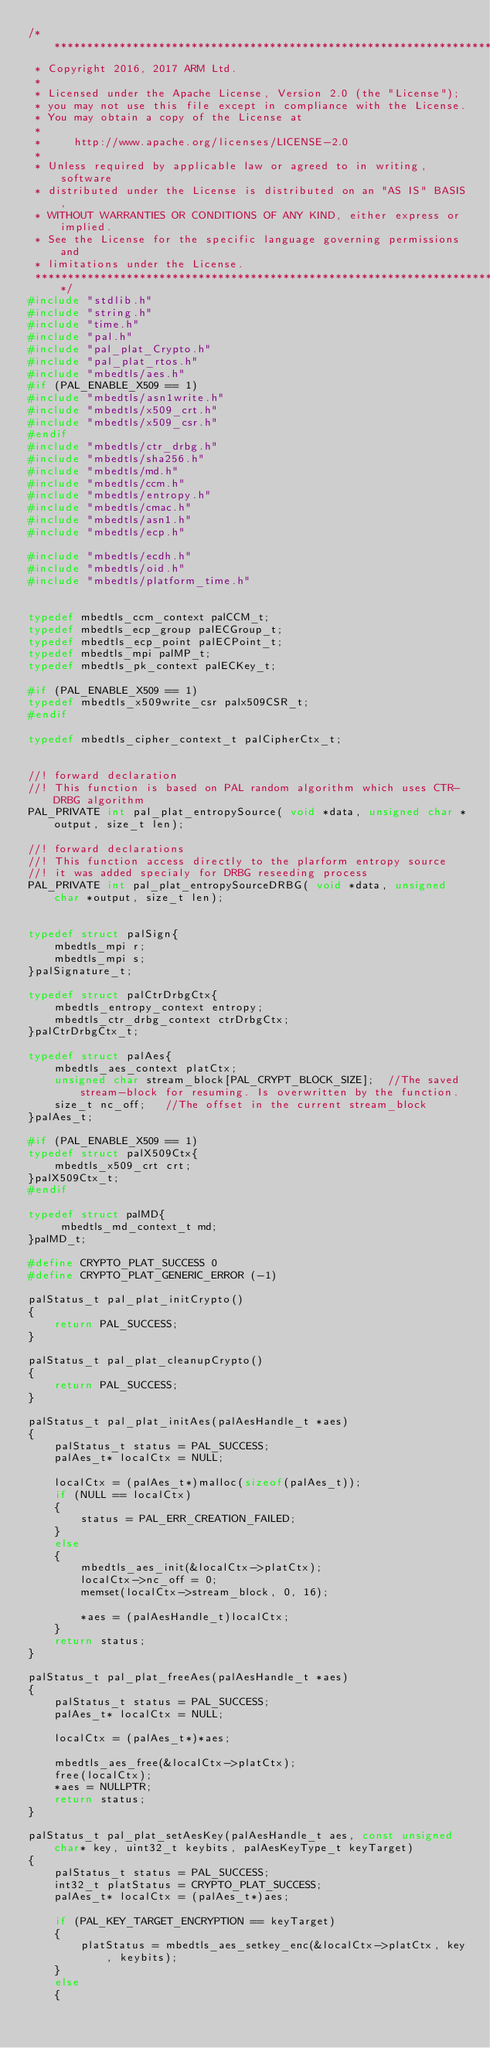<code> <loc_0><loc_0><loc_500><loc_500><_C_>/*******************************************************************************
 * Copyright 2016, 2017 ARM Ltd.
 *
 * Licensed under the Apache License, Version 2.0 (the "License");
 * you may not use this file except in compliance with the License.
 * You may obtain a copy of the License at
 *
 *     http://www.apache.org/licenses/LICENSE-2.0
 *
 * Unless required by applicable law or agreed to in writing, software
 * distributed under the License is distributed on an "AS IS" BASIS,
 * WITHOUT WARRANTIES OR CONDITIONS OF ANY KIND, either express or implied.
 * See the License for the specific language governing permissions and
 * limitations under the License.
 *******************************************************************************/
#include "stdlib.h"
#include "string.h"
#include "time.h"
#include "pal.h"
#include "pal_plat_Crypto.h"
#include "pal_plat_rtos.h"
#include "mbedtls/aes.h"
#if (PAL_ENABLE_X509 == 1)
#include "mbedtls/asn1write.h"
#include "mbedtls/x509_crt.h"
#include "mbedtls/x509_csr.h"
#endif 
#include "mbedtls/ctr_drbg.h"
#include "mbedtls/sha256.h"
#include "mbedtls/md.h"
#include "mbedtls/ccm.h"
#include "mbedtls/entropy.h"
#include "mbedtls/cmac.h"
#include "mbedtls/asn1.h"
#include "mbedtls/ecp.h"

#include "mbedtls/ecdh.h"
#include "mbedtls/oid.h"
#include "mbedtls/platform_time.h"


typedef mbedtls_ccm_context palCCM_t;
typedef mbedtls_ecp_group palECGroup_t;
typedef mbedtls_ecp_point palECPoint_t;
typedef mbedtls_mpi palMP_t;
typedef mbedtls_pk_context palECKey_t;

#if (PAL_ENABLE_X509 == 1)
typedef mbedtls_x509write_csr palx509CSR_t; 
#endif

typedef mbedtls_cipher_context_t palCipherCtx_t;


//! forward declaration
//! This function is based on PAL random algorithm which uses CTR-DRBG algorithm
PAL_PRIVATE int pal_plat_entropySource( void *data, unsigned char *output, size_t len);

//! forward declarations
//! This function access directly to the plarform entropy source
//! it was added specialy for DRBG reseeding process
PAL_PRIVATE int pal_plat_entropySourceDRBG( void *data, unsigned char *output, size_t len);


typedef struct palSign{
    mbedtls_mpi r;
    mbedtls_mpi s;
}palSignature_t;

typedef struct palCtrDrbgCtx{
    mbedtls_entropy_context entropy;
    mbedtls_ctr_drbg_context ctrDrbgCtx;
}palCtrDrbgCtx_t;

typedef struct palAes{
    mbedtls_aes_context platCtx;
    unsigned char stream_block[PAL_CRYPT_BLOCK_SIZE];  //The saved stream-block for resuming. Is overwritten by the function.
    size_t nc_off;   //The offset in the current stream_block
}palAes_t;

#if (PAL_ENABLE_X509 == 1)
typedef struct palX509Ctx{
    mbedtls_x509_crt crt;
}palX509Ctx_t;
#endif

typedef struct palMD{
     mbedtls_md_context_t md;
}palMD_t;

#define CRYPTO_PLAT_SUCCESS 0
#define CRYPTO_PLAT_GENERIC_ERROR (-1)

palStatus_t pal_plat_initCrypto()
{
    return PAL_SUCCESS;
}

palStatus_t pal_plat_cleanupCrypto()
{
    return PAL_SUCCESS;
}

palStatus_t pal_plat_initAes(palAesHandle_t *aes)
{
    palStatus_t status = PAL_SUCCESS;
    palAes_t* localCtx = NULL;

    localCtx = (palAes_t*)malloc(sizeof(palAes_t));
    if (NULL == localCtx)
    {
        status = PAL_ERR_CREATION_FAILED;
    }
    else
    {
        mbedtls_aes_init(&localCtx->platCtx);
        localCtx->nc_off = 0;
        memset(localCtx->stream_block, 0, 16);

        *aes = (palAesHandle_t)localCtx;
    }
    return status;
}

palStatus_t pal_plat_freeAes(palAesHandle_t *aes)
{
    palStatus_t status = PAL_SUCCESS;
    palAes_t* localCtx = NULL;
    
    localCtx = (palAes_t*)*aes;
    
    mbedtls_aes_free(&localCtx->platCtx);
    free(localCtx);
    *aes = NULLPTR;
    return status;
}

palStatus_t pal_plat_setAesKey(palAesHandle_t aes, const unsigned char* key, uint32_t keybits, palAesKeyType_t keyTarget)
{
    palStatus_t status = PAL_SUCCESS;
    int32_t platStatus = CRYPTO_PLAT_SUCCESS;
    palAes_t* localCtx = (palAes_t*)aes;

    if (PAL_KEY_TARGET_ENCRYPTION == keyTarget)
    {
        platStatus = mbedtls_aes_setkey_enc(&localCtx->platCtx, key, keybits);
    }
    else
    {</code> 